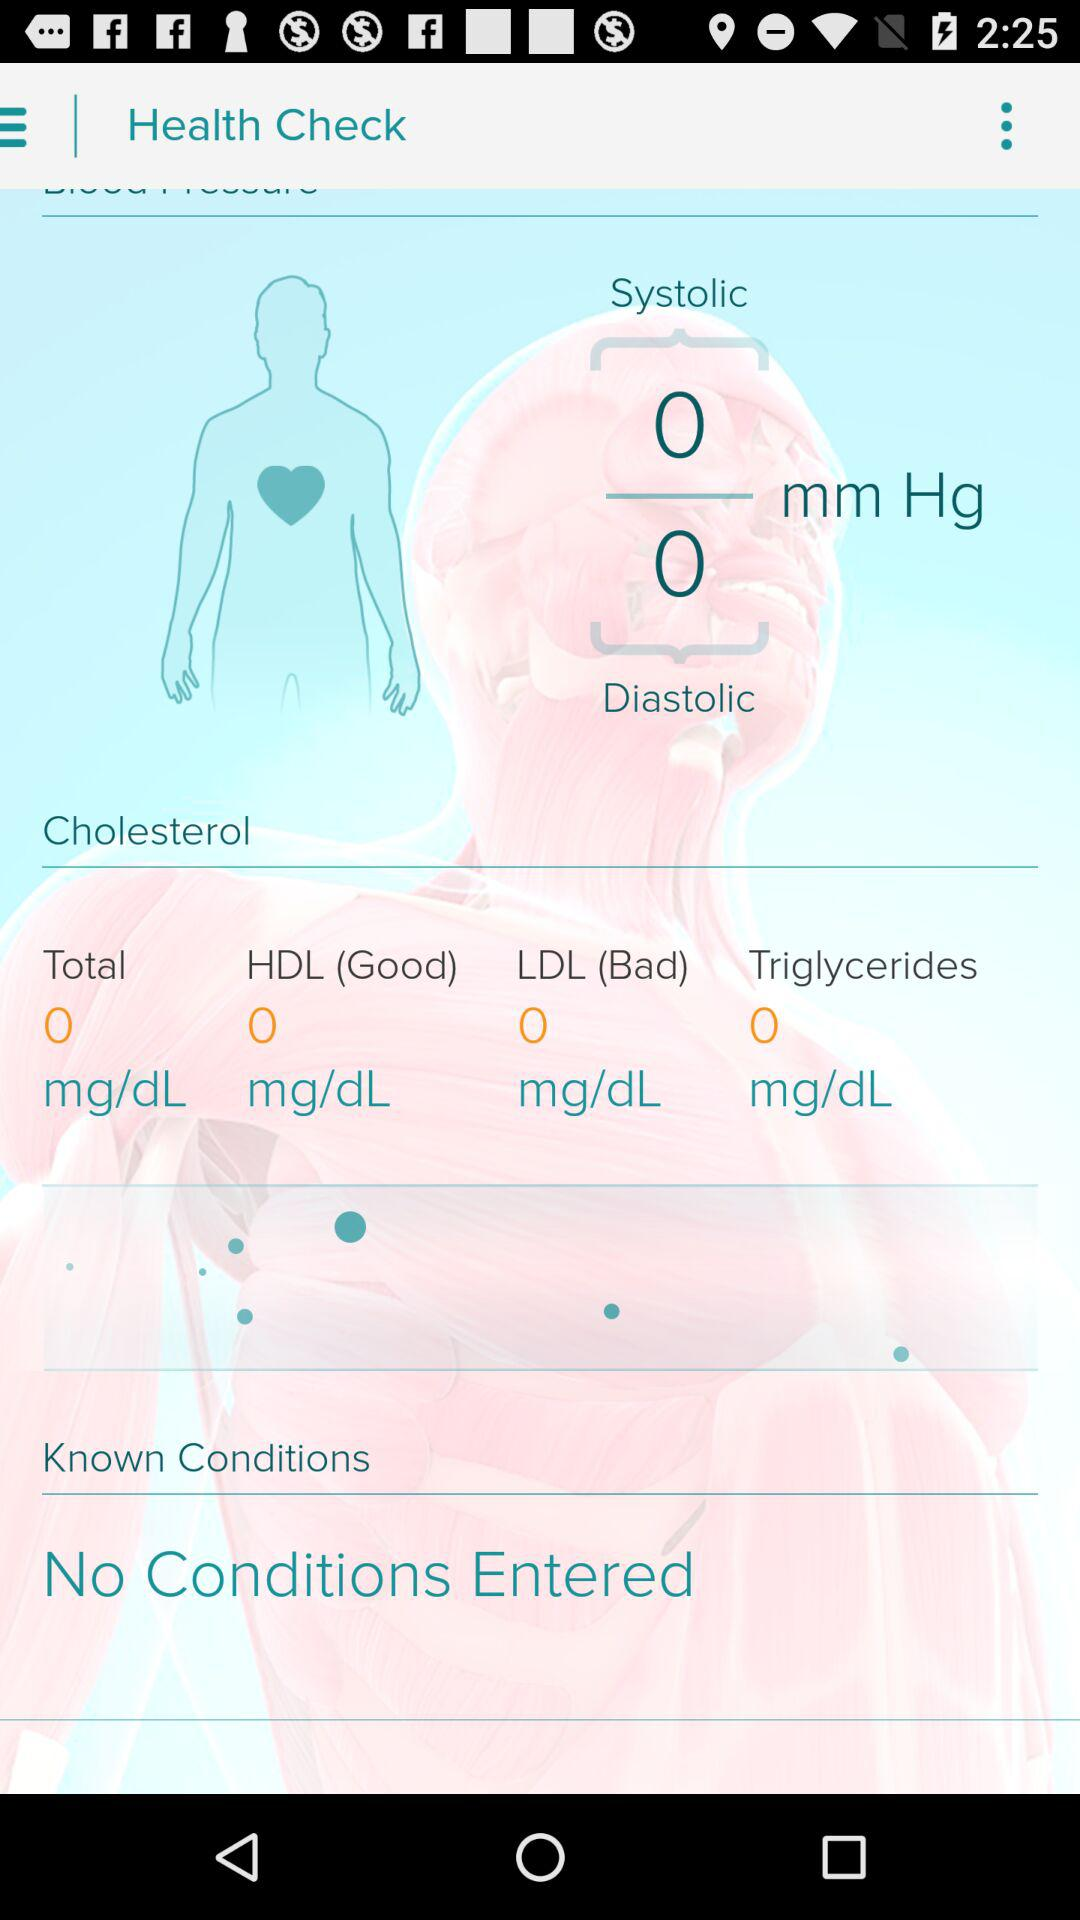What is the measured value of "Systolic" and "Diastolic" blood pressure? The measured value of "Systolic" blood pressure is 0 mm Hg and the measured value of "Diastolic" blood pressure is 0 mm Hg. 